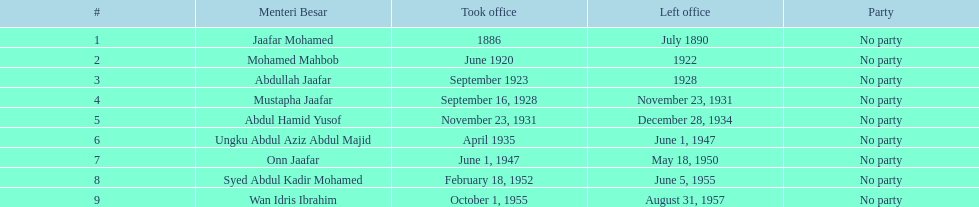Who took office after onn jaafar? Syed Abdul Kadir Mohamed. 